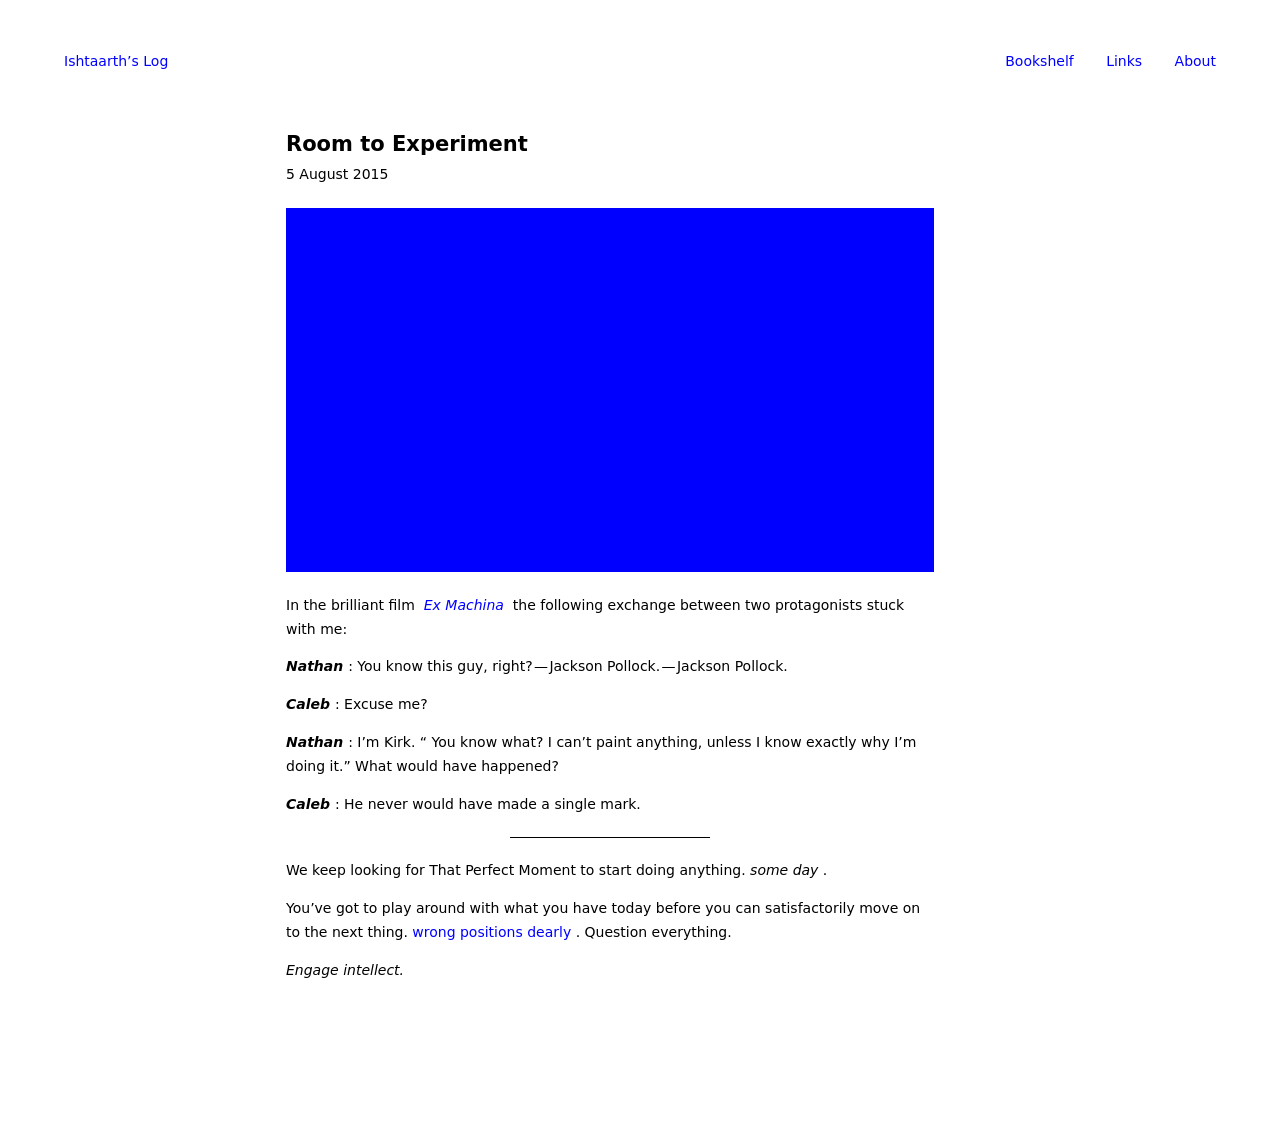Can you explain the significance of the solid blue square in the context of the webpage? The solid blue square in the image likely represents a focus on minimalism or a specific artistic approach that prioritizes simplicity and impactful visual elements. In a webpage context, such a design choice might be used to draw attention to a particular area of the page or to evoke a certain emotion or brand identity linked with the color and the minimalistic approach.  Could you provide some inspiration or examples of how minimalist design is effectively used in other websites? Certainly! Minimalist design is often characterized by clean lines, ample white space, and a restricted color palette. Websites like Apple’s homepage provide a classic example of this, using vast white or light spaces and focusing on the essential components only. Another example is the Google Search homepage, notable for its simplicity, proving that a minimalist approach can be both aesthetically pleasing and functionally efficient. 